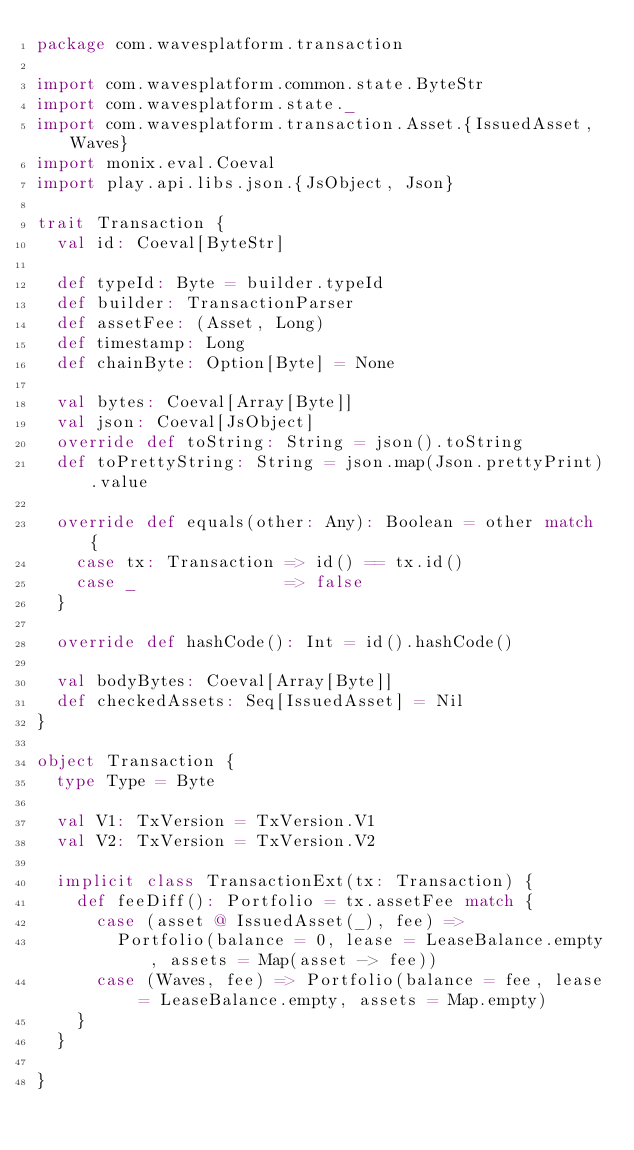Convert code to text. <code><loc_0><loc_0><loc_500><loc_500><_Scala_>package com.wavesplatform.transaction

import com.wavesplatform.common.state.ByteStr
import com.wavesplatform.state._
import com.wavesplatform.transaction.Asset.{IssuedAsset, Waves}
import monix.eval.Coeval
import play.api.libs.json.{JsObject, Json}

trait Transaction {
  val id: Coeval[ByteStr]

  def typeId: Byte = builder.typeId
  def builder: TransactionParser
  def assetFee: (Asset, Long)
  def timestamp: Long
  def chainByte: Option[Byte] = None

  val bytes: Coeval[Array[Byte]]
  val json: Coeval[JsObject]
  override def toString: String = json().toString
  def toPrettyString: String = json.map(Json.prettyPrint).value

  override def equals(other: Any): Boolean = other match {
    case tx: Transaction => id() == tx.id()
    case _               => false
  }

  override def hashCode(): Int = id().hashCode()

  val bodyBytes: Coeval[Array[Byte]]
  def checkedAssets: Seq[IssuedAsset] = Nil
}

object Transaction {
  type Type = Byte

  val V1: TxVersion = TxVersion.V1
  val V2: TxVersion = TxVersion.V2

  implicit class TransactionExt(tx: Transaction) {
    def feeDiff(): Portfolio = tx.assetFee match {
      case (asset @ IssuedAsset(_), fee) =>
        Portfolio(balance = 0, lease = LeaseBalance.empty, assets = Map(asset -> fee))
      case (Waves, fee) => Portfolio(balance = fee, lease = LeaseBalance.empty, assets = Map.empty)
    }
  }

}
</code> 